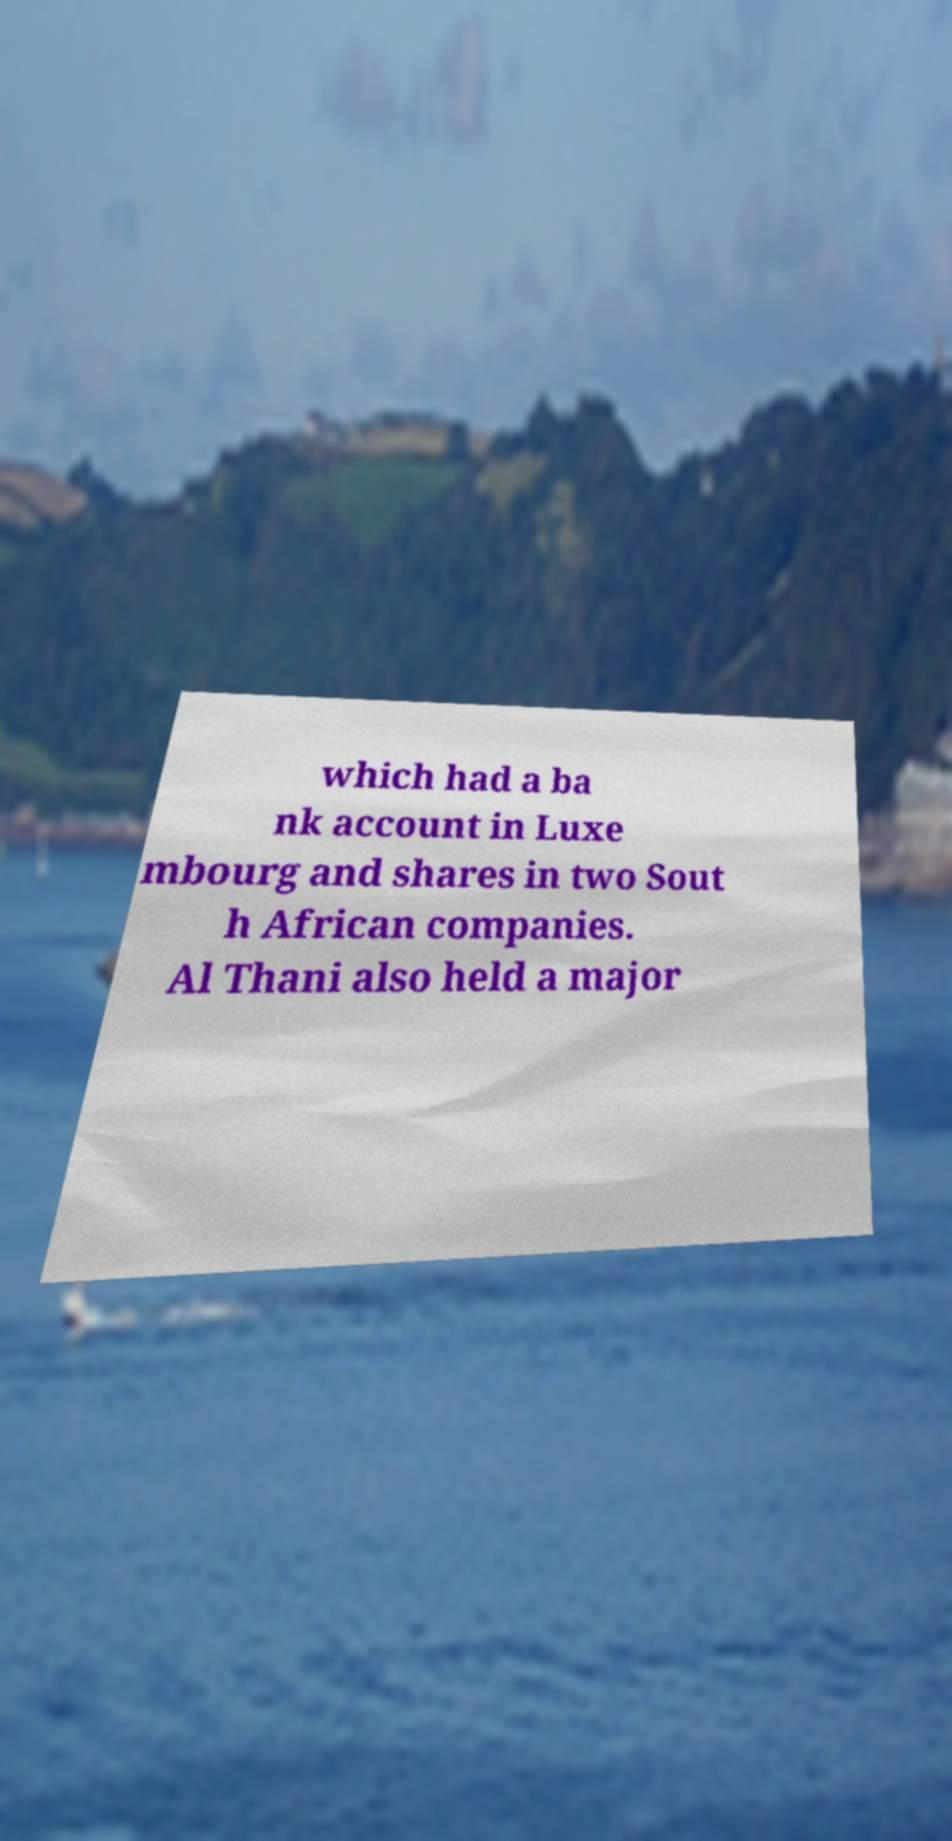Please identify and transcribe the text found in this image. which had a ba nk account in Luxe mbourg and shares in two Sout h African companies. Al Thani also held a major 